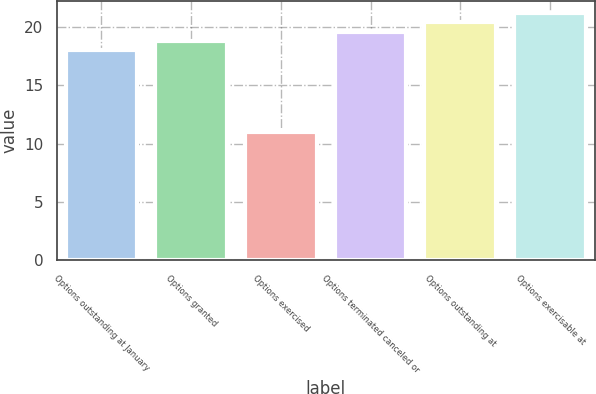Convert chart. <chart><loc_0><loc_0><loc_500><loc_500><bar_chart><fcel>Options outstanding at January<fcel>Options granted<fcel>Options exercised<fcel>Options terminated canceled or<fcel>Options outstanding at<fcel>Options exercisable at<nl><fcel>18<fcel>18.8<fcel>11<fcel>19.6<fcel>20.4<fcel>21.2<nl></chart> 